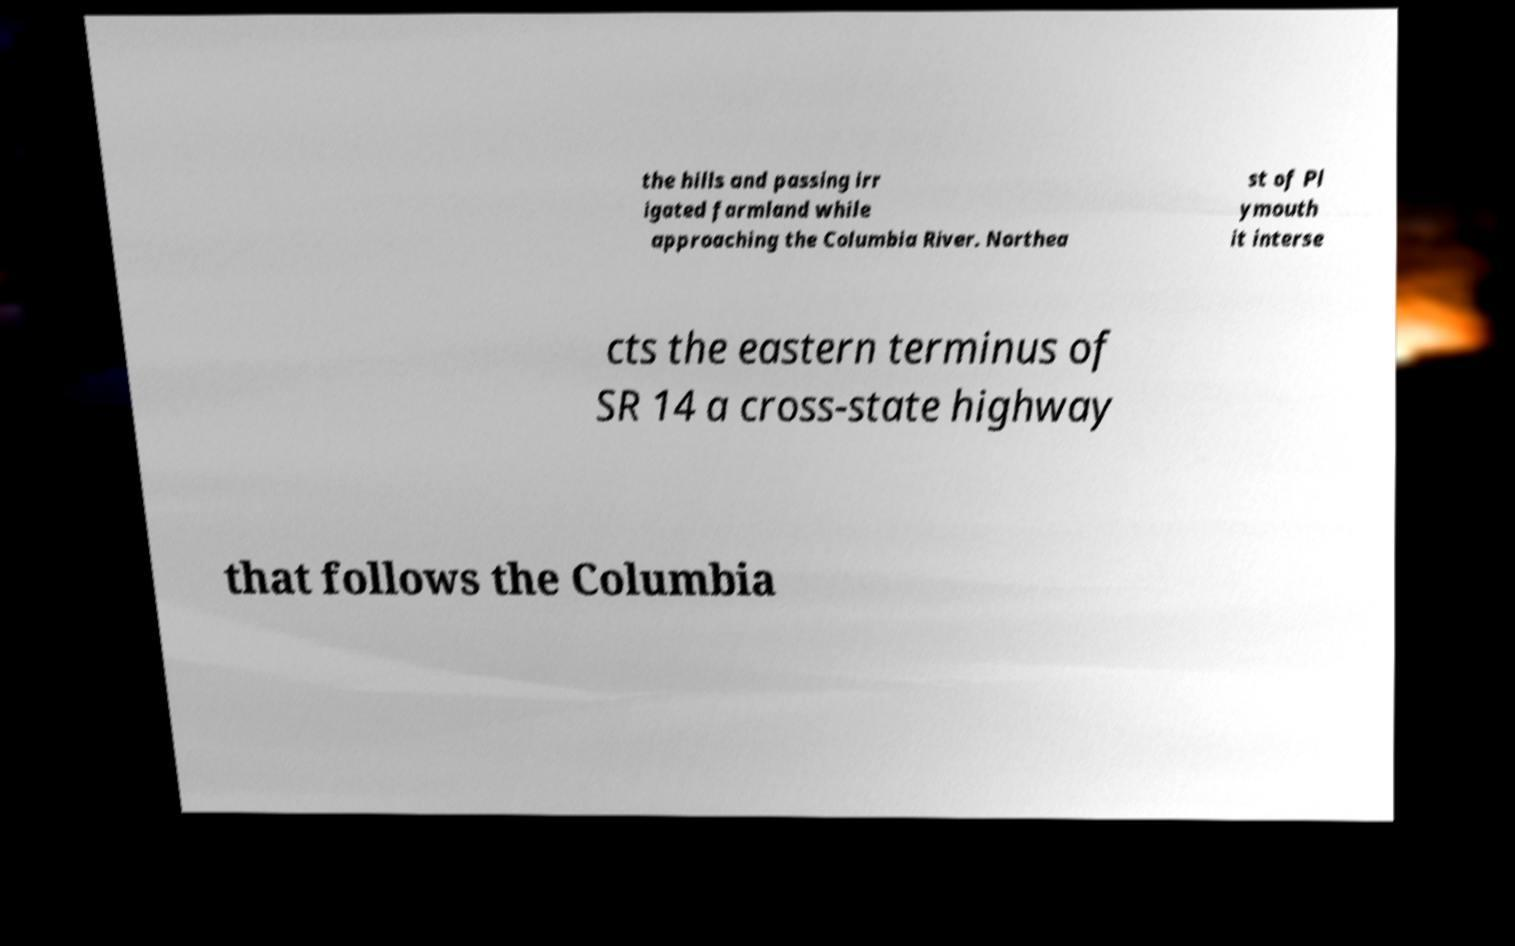Could you extract and type out the text from this image? the hills and passing irr igated farmland while approaching the Columbia River. Northea st of Pl ymouth it interse cts the eastern terminus of SR 14 a cross-state highway that follows the Columbia 